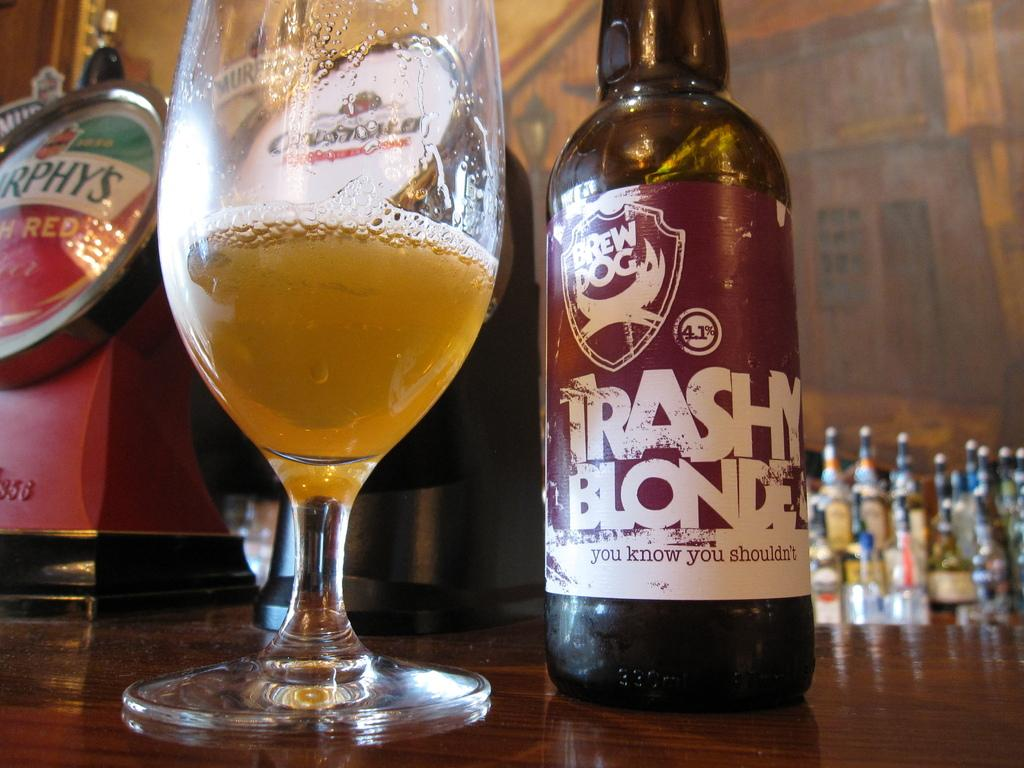What type of beverage is featured in the image? There is a bottle of beer and a glass of beer in the image. Where are the bottle and glass of beer located? Both the bottle and glass of beer are present on a table. What time of day is it at the lake in the image? There is no lake present in the image, so it is not possible to determine the time of day at a lake. 